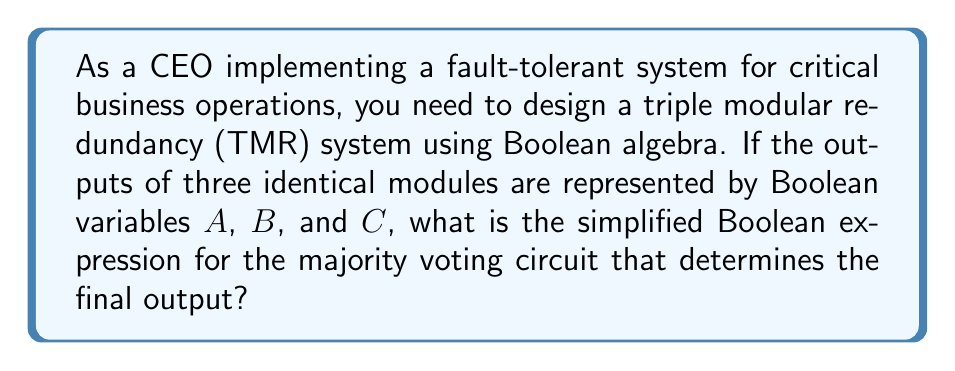What is the answer to this math problem? Let's approach this step-by-step:

1) In a TMR system, the final output is determined by a majority vote of the three modules. This means the output will be true if at least two of the three modules output true.

2) We can express this using Boolean algebra as:

   $$(A \land B) \lor (B \land C) \lor (A \land C)$$

3) This expression represents all possible combinations where at least two variables are true.

4) To simplify this expression, we can use the distributive law of Boolean algebra:

   $$(A \land B) \lor (A \land C) \lor (B \land C)$$
   $$= A \land (B \lor C) \lor (B \land C)$$

5) Using the absorption law $(X \lor (X \land Y) = X)$, we can further simplify:

   $$A \land (B \lor C) \lor (B \land C)$$
   $$= (A \land B) \lor (A \land C) \lor (B \land C)$$

6) This is our final, simplified expression for the majority voting circuit.

This implementation ensures fault tolerance by producing the correct output even if one of the three modules fails, making it crucial for critical business operations.
Answer: $(A \land B) \lor (A \land C) \lor (B \land C)$ 